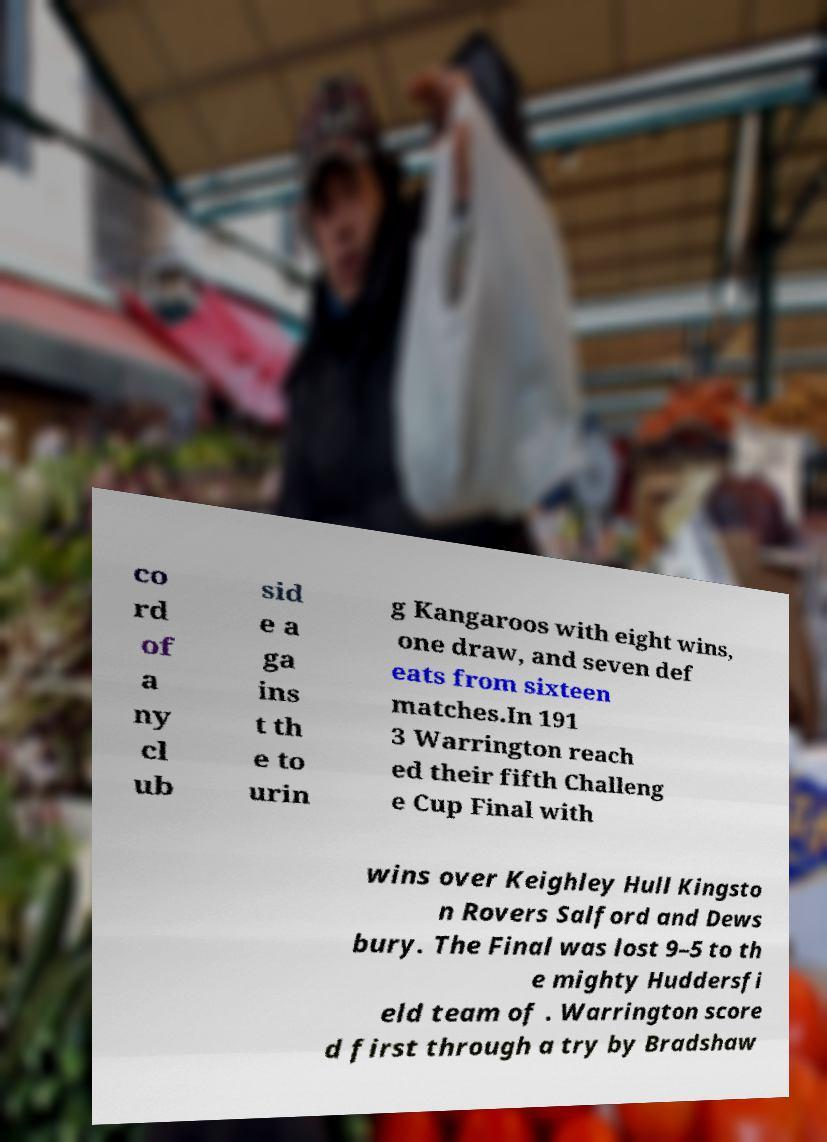Can you accurately transcribe the text from the provided image for me? co rd of a ny cl ub sid e a ga ins t th e to urin g Kangaroos with eight wins, one draw, and seven def eats from sixteen matches.In 191 3 Warrington reach ed their fifth Challeng e Cup Final with wins over Keighley Hull Kingsto n Rovers Salford and Dews bury. The Final was lost 9–5 to th e mighty Huddersfi eld team of . Warrington score d first through a try by Bradshaw 